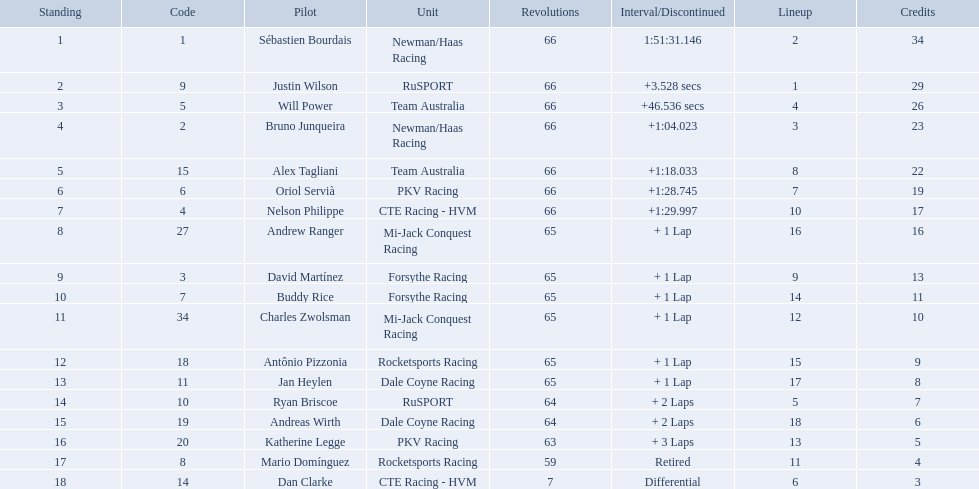Which teams participated in the 2006 gran premio telmex? Newman/Haas Racing, RuSPORT, Team Australia, Newman/Haas Racing, Team Australia, PKV Racing, CTE Racing - HVM, Mi-Jack Conquest Racing, Forsythe Racing, Forsythe Racing, Mi-Jack Conquest Racing, Rocketsports Racing, Dale Coyne Racing, RuSPORT, Dale Coyne Racing, PKV Racing, Rocketsports Racing, CTE Racing - HVM. Who were the drivers of these teams? Sébastien Bourdais, Justin Wilson, Will Power, Bruno Junqueira, Alex Tagliani, Oriol Servià, Nelson Philippe, Andrew Ranger, David Martínez, Buddy Rice, Charles Zwolsman, Antônio Pizzonia, Jan Heylen, Ryan Briscoe, Andreas Wirth, Katherine Legge, Mario Domínguez, Dan Clarke. Which driver finished last? Dan Clarke. Who are all of the 2006 gran premio telmex drivers? Sébastien Bourdais, Justin Wilson, Will Power, Bruno Junqueira, Alex Tagliani, Oriol Servià, Nelson Philippe, Andrew Ranger, David Martínez, Buddy Rice, Charles Zwolsman, Antônio Pizzonia, Jan Heylen, Ryan Briscoe, Andreas Wirth, Katherine Legge, Mario Domínguez, Dan Clarke. How many laps did they finish? 66, 66, 66, 66, 66, 66, 66, 65, 65, 65, 65, 65, 65, 64, 64, 63, 59, 7. What about just oriol servia and katherine legge? 66, 63. And which of those two drivers finished more laps? Oriol Servià. Which drivers scored at least 10 points? Sébastien Bourdais, Justin Wilson, Will Power, Bruno Junqueira, Alex Tagliani, Oriol Servià, Nelson Philippe, Andrew Ranger, David Martínez, Buddy Rice, Charles Zwolsman. Of those drivers, which ones scored at least 20 points? Sébastien Bourdais, Justin Wilson, Will Power, Bruno Junqueira, Alex Tagliani. Of those 5, which driver scored the most points? Sébastien Bourdais. Which people scored 29+ points? Sébastien Bourdais, Justin Wilson. Who scored higher? Sébastien Bourdais. What are the drivers numbers? 1, 9, 5, 2, 15, 6, 4, 27, 3, 7, 34, 18, 11, 10, 19, 20, 8, 14. Are there any who's number matches his position? Sébastien Bourdais, Oriol Servià. Of those two who has the highest position? Sébastien Bourdais. Who are the drivers? Sébastien Bourdais, Justin Wilson, Will Power, Bruno Junqueira, Alex Tagliani, Oriol Servià, Nelson Philippe, Andrew Ranger, David Martínez, Buddy Rice, Charles Zwolsman, Antônio Pizzonia, Jan Heylen, Ryan Briscoe, Andreas Wirth, Katherine Legge, Mario Domínguez, Dan Clarke. What are their numbers? 1, 9, 5, 2, 15, 6, 4, 27, 3, 7, 34, 18, 11, 10, 19, 20, 8, 14. What are their positions? 1, 2, 3, 4, 5, 6, 7, 8, 9, 10, 11, 12, 13, 14, 15, 16, 17, 18. Which driver has the same number and position? Sébastien Bourdais. Who are all the drivers? Sébastien Bourdais, Justin Wilson, Will Power, Bruno Junqueira, Alex Tagliani, Oriol Servià, Nelson Philippe, Andrew Ranger, David Martínez, Buddy Rice, Charles Zwolsman, Antônio Pizzonia, Jan Heylen, Ryan Briscoe, Andreas Wirth, Katherine Legge, Mario Domínguez, Dan Clarke. What position did they reach? 1, 2, 3, 4, 5, 6, 7, 8, 9, 10, 11, 12, 13, 14, 15, 16, 17, 18. What is the number for each driver? 1, 9, 5, 2, 15, 6, 4, 27, 3, 7, 34, 18, 11, 10, 19, 20, 8, 14. And which player's number and position match? Sébastien Bourdais. 